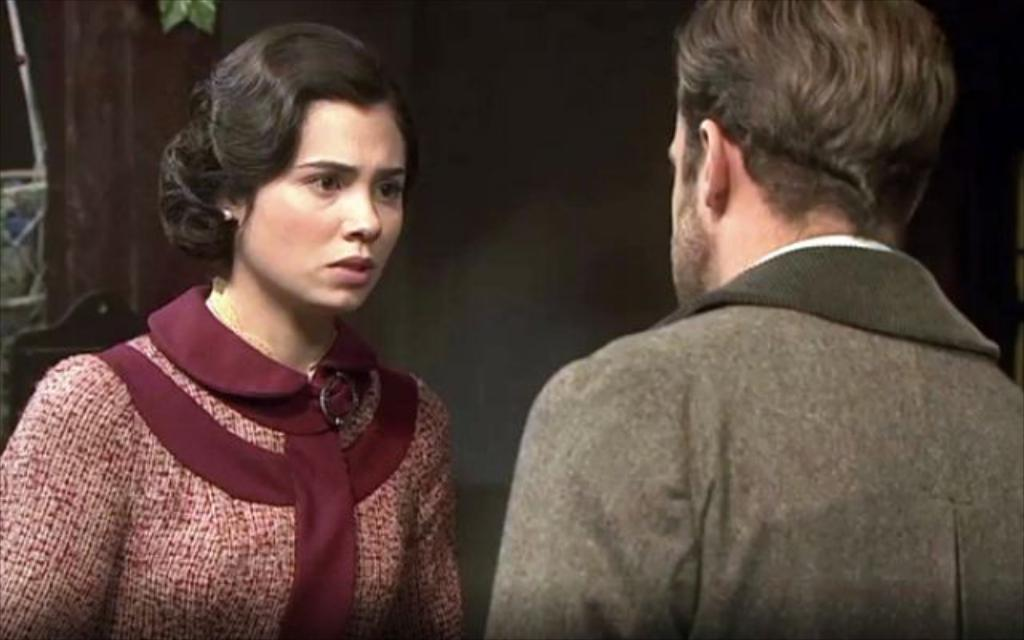Who are the main subjects in the image? There is a man and a woman in the center of the image. What are the man and woman doing in the image? The man and woman are standing and talking. What can be seen in the background of the image? There is a wall in the background of the image. How many deer are visible in the image? There are no deer present in the image. What type of doll is the man holding in the image? There is no doll present in the image. 